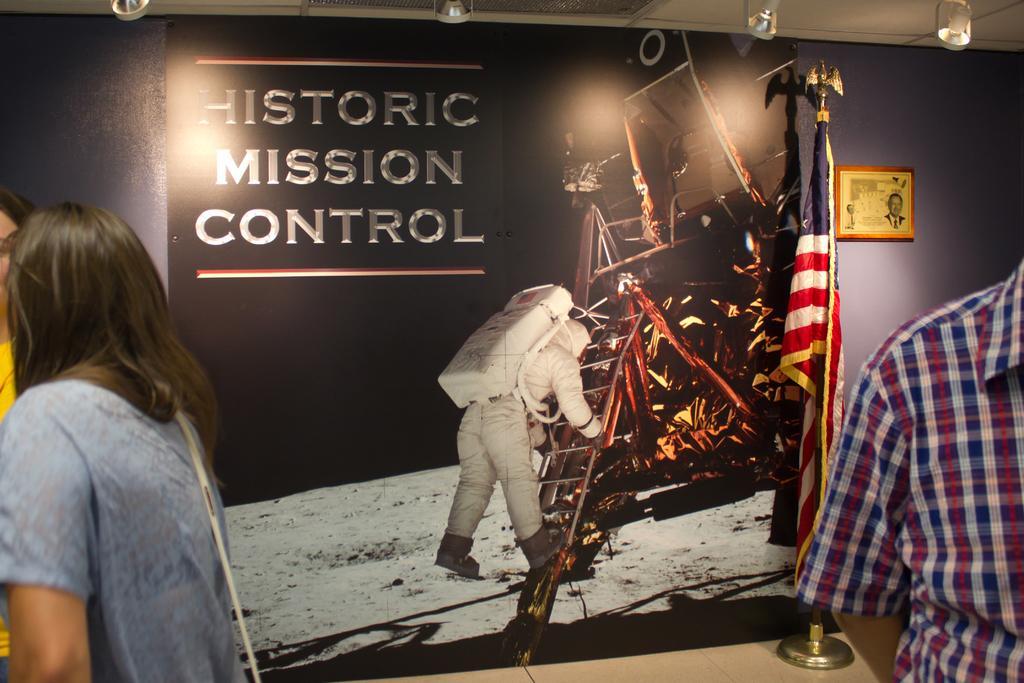Please provide a concise description of this image. On the left side, there are two persons standing. On the right side, there is a person in a shirt. In the background, there is a wallpaper on the wall, there is a flag and there are lights attached to the roof. 